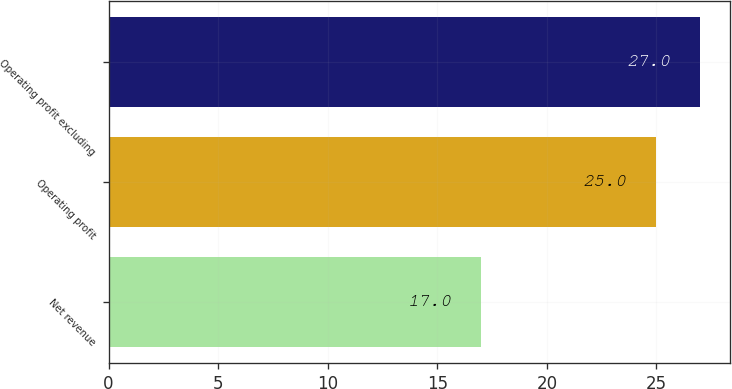Convert chart. <chart><loc_0><loc_0><loc_500><loc_500><bar_chart><fcel>Net revenue<fcel>Operating profit<fcel>Operating profit excluding<nl><fcel>17<fcel>25<fcel>27<nl></chart> 